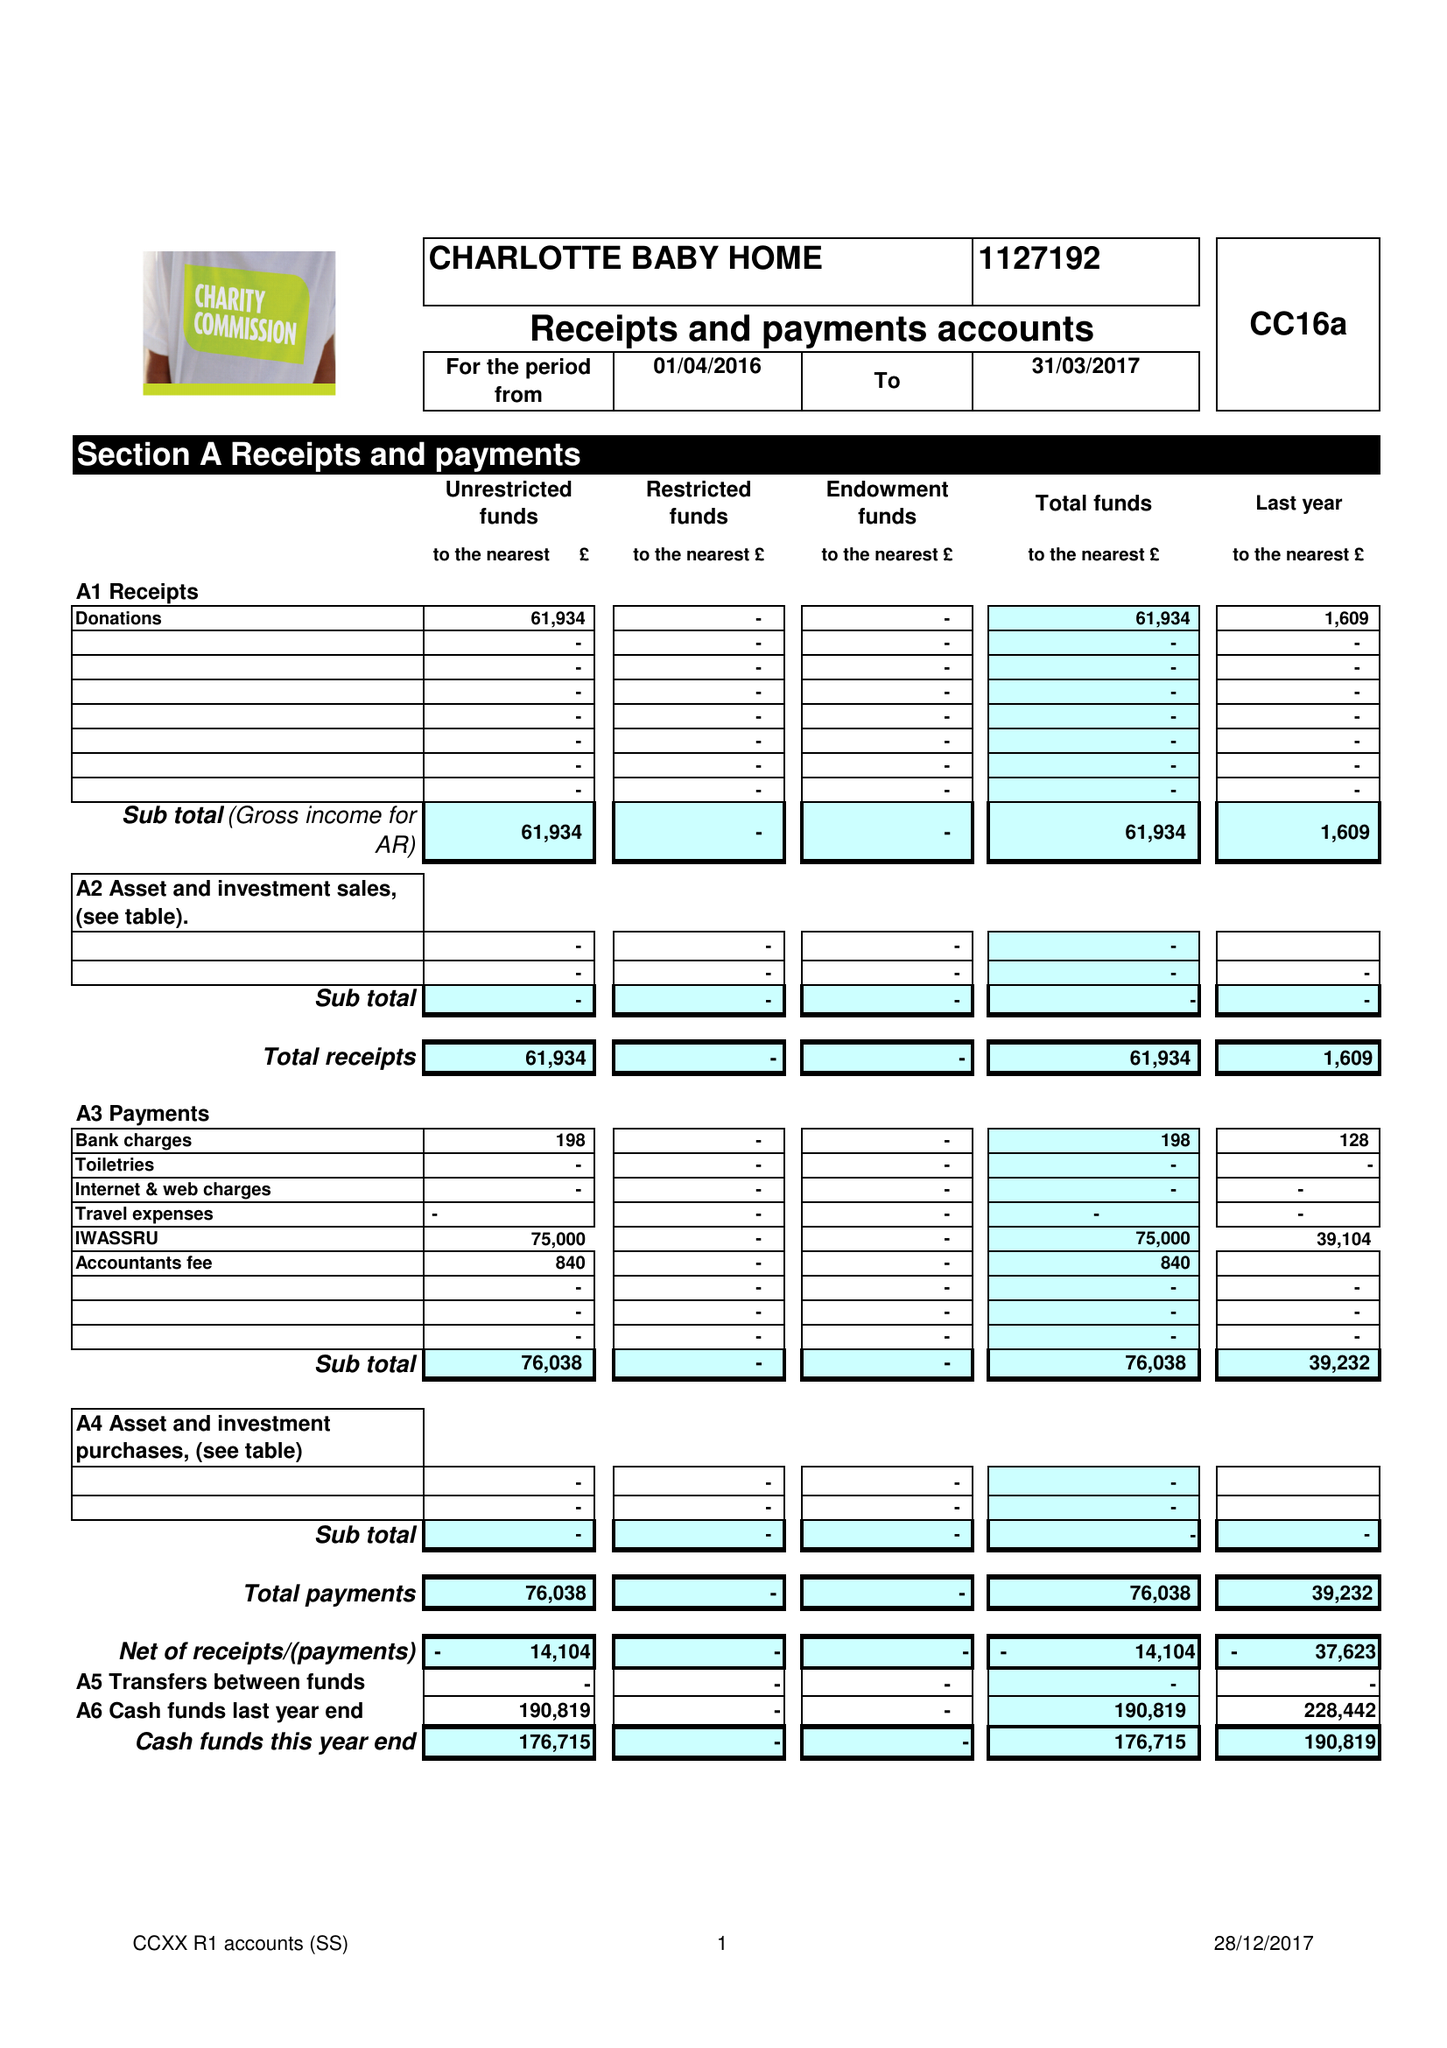What is the value for the charity_name?
Answer the question using a single word or phrase. Charlotte Baby Home 